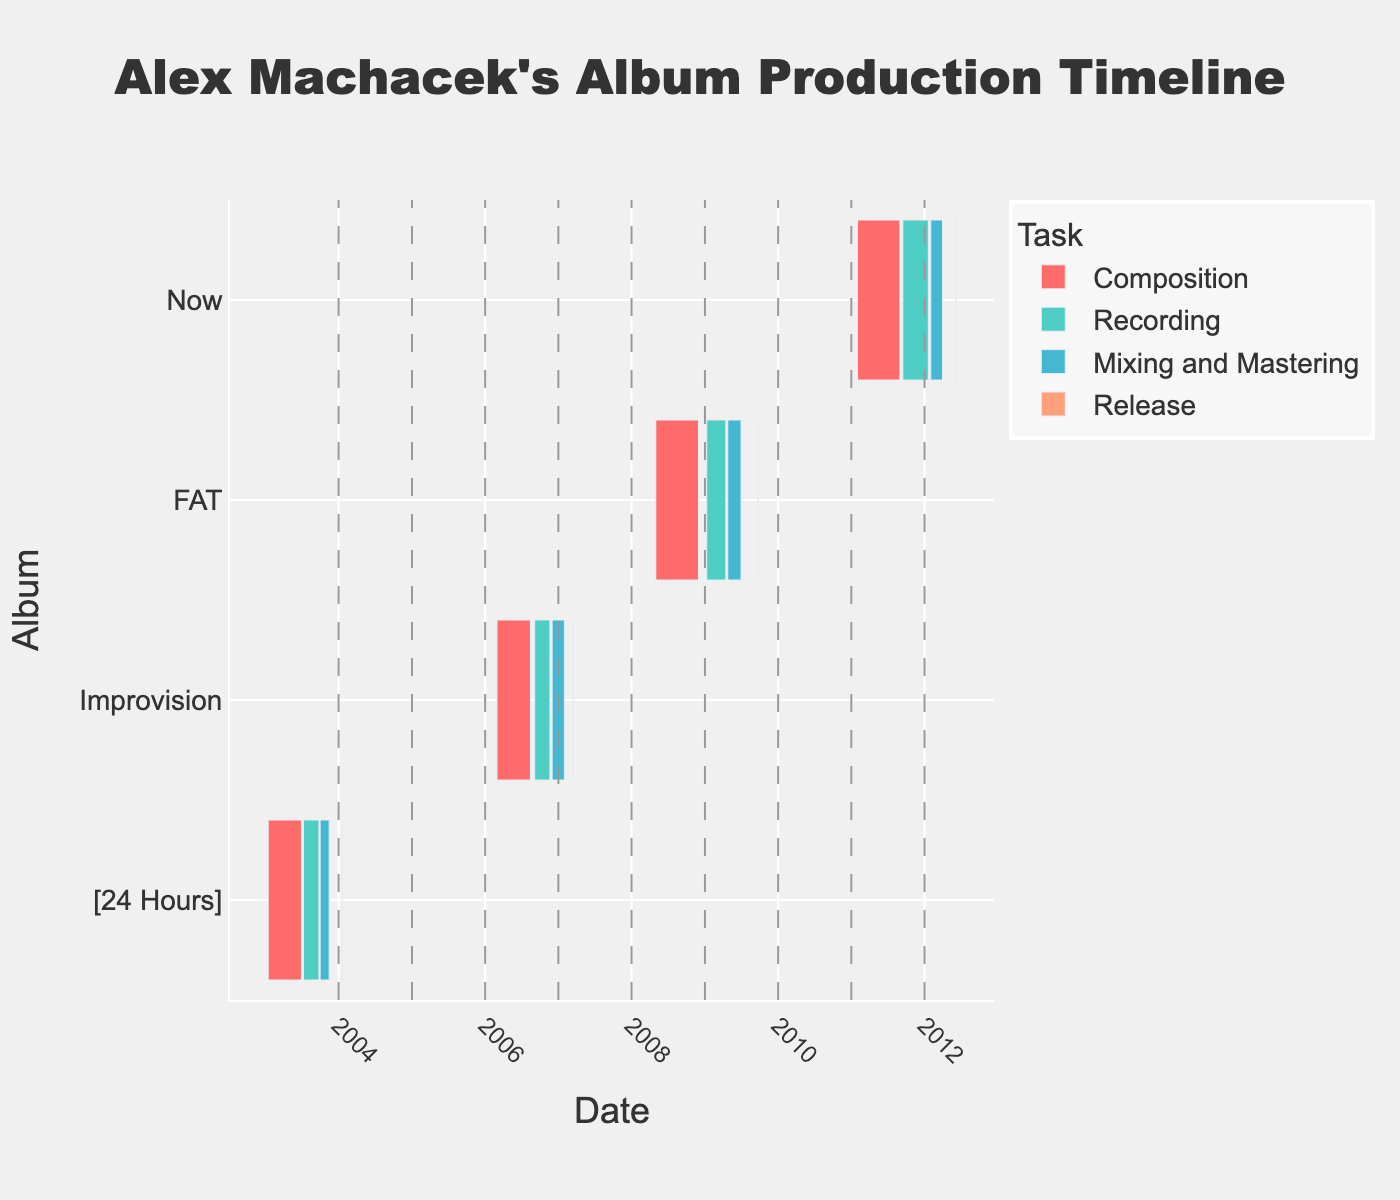how many albums are displayed on this timeline? The Gantt chart labels its y-axis with the 'Album' names, and there are four distinct album names in the data. By counting these labels, we can determine how many albums are represented.
Answer: Four which task has the shortest duration for the album '24 Hours'? The Gantt chart uses different colored bars to represent different tasks. By examining the bars corresponding to the '24 Hours' album, the 'Release' task is the one with the shortest duration as it spans only a single day, January 20, 2004.
Answer: Release how much time did Alex Machacek spend recording the album 'Improvision'? From the Gantt chart, the recording task for 'Improvision' starts on September 5, 2006 and ends on November 20, 2006. By calculating the difference between these dates, we can determine the recording duration.
Answer: 77 days which album took the longest time from the start of composition to the release date? To find this, we examine the total duration from the start of the composition to the release date for each album by looking at the bars on the Gantt chart. 'FAT' started composition on May 1, 2008 and released on September 22, 2009, making it the longest duration.
Answer: FAT how does the recording period of 'Now' compare to that of 'FAT'? By examining the bars representing the recording periods for 'Now' and 'FAT', we observe that the recording period for 'Now' is longer than for 'FAT'. 'Now' spans from September 15, 2011 to January 20, 2012, while 'FAT' spans from January 10, 2009 to April 15, 2009.
Answer: Now is longer what is the average duration of the mixing and mastering tasks across all albums? We add the duration of the mixing and mastering tasks for each album: (7+61+66+59) days, and divide by the number of albums (4). The total duration is 193 days, so the average is 193/4.
Answer: 48.25 days which task for the album 'Improvision' was completed first? Examining the timeline for 'Improvision', we see the composition task finishes first on August 15, 2006, before any other tasks.
Answer: Composition 